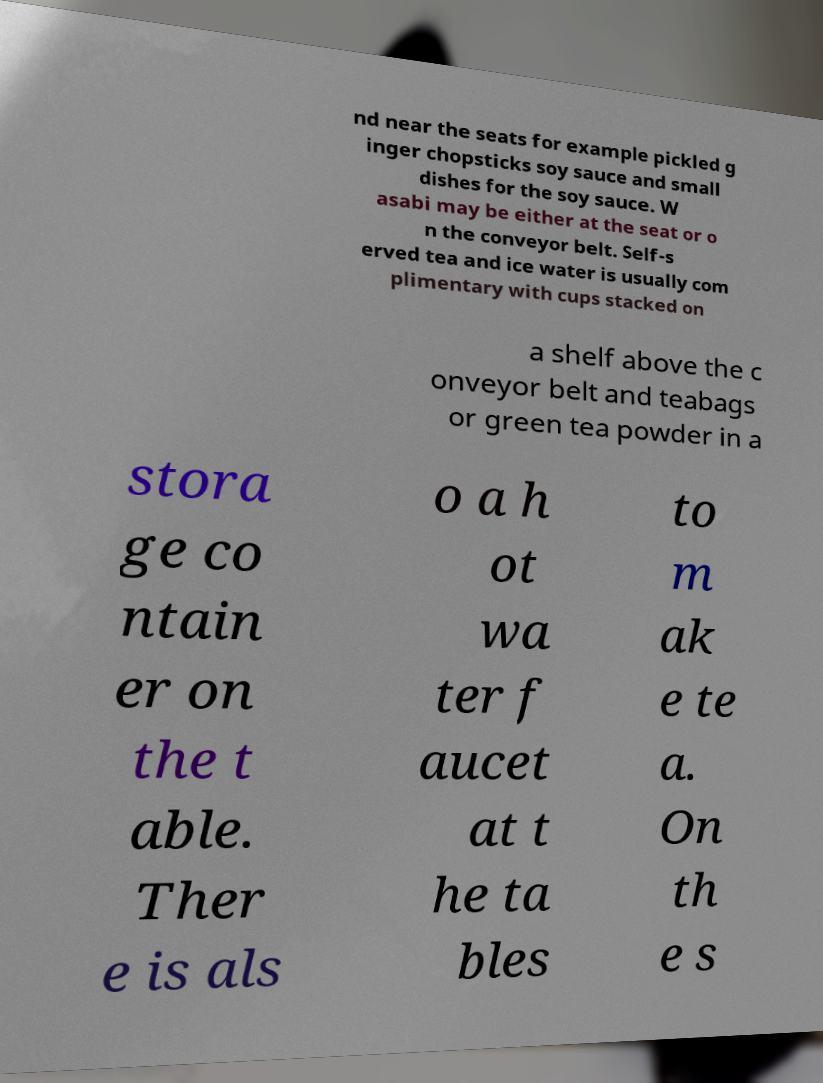What messages or text are displayed in this image? I need them in a readable, typed format. nd near the seats for example pickled g inger chopsticks soy sauce and small dishes for the soy sauce. W asabi may be either at the seat or o n the conveyor belt. Self-s erved tea and ice water is usually com plimentary with cups stacked on a shelf above the c onveyor belt and teabags or green tea powder in a stora ge co ntain er on the t able. Ther e is als o a h ot wa ter f aucet at t he ta bles to m ak e te a. On th e s 